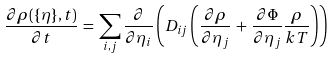<formula> <loc_0><loc_0><loc_500><loc_500>\frac { \partial \rho ( \{ \eta \} , t ) } { \partial t } \, = \, \sum _ { i , j } \frac { \partial } { \partial \eta _ { i } } \left ( D _ { i j } \left ( \frac { \partial \rho } { \partial \eta _ { j } } \, + \, \frac { \partial \Phi } { \partial \eta _ { j } } \frac { \rho } { k T } \right ) \right )</formula> 